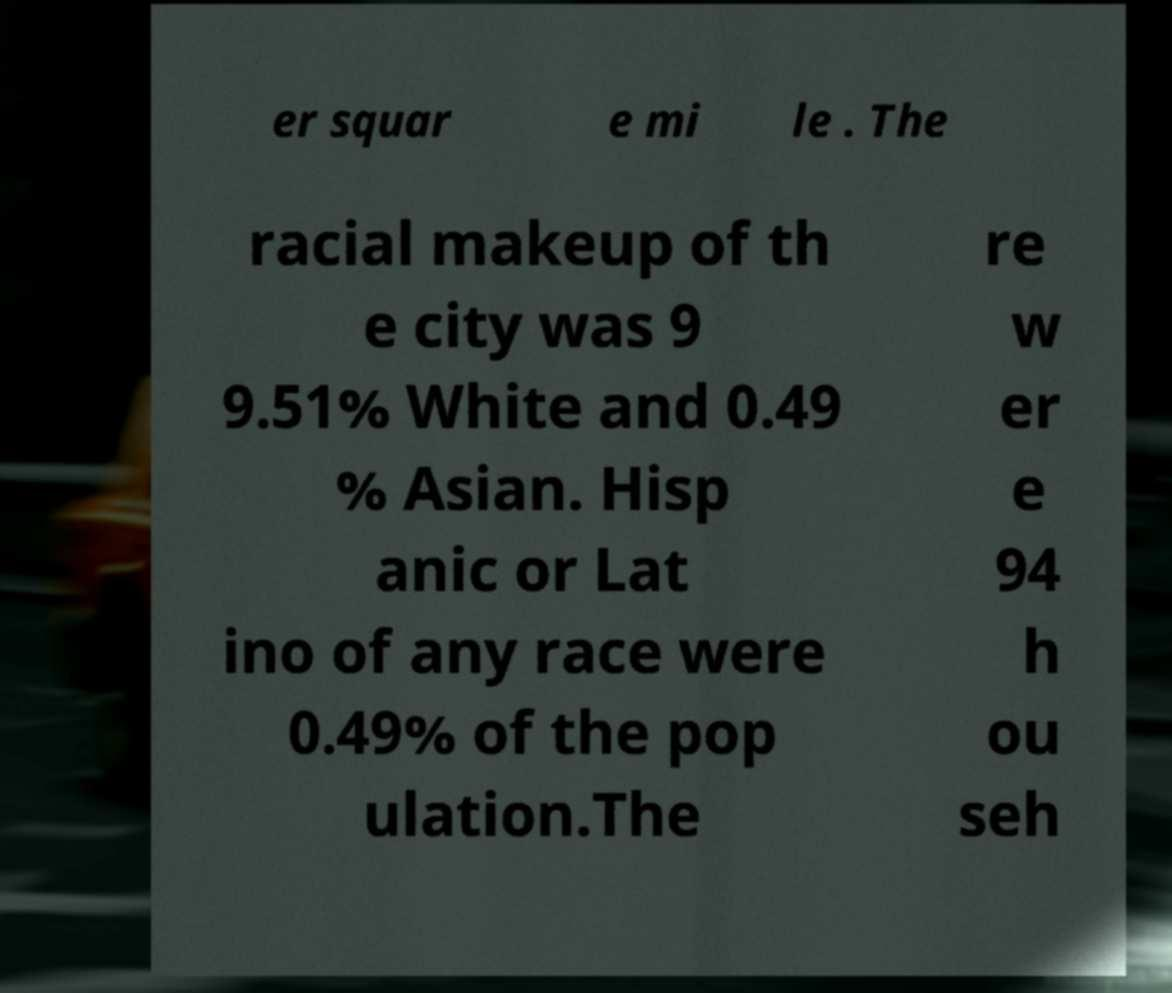Please identify and transcribe the text found in this image. er squar e mi le . The racial makeup of th e city was 9 9.51% White and 0.49 % Asian. Hisp anic or Lat ino of any race were 0.49% of the pop ulation.The re w er e 94 h ou seh 